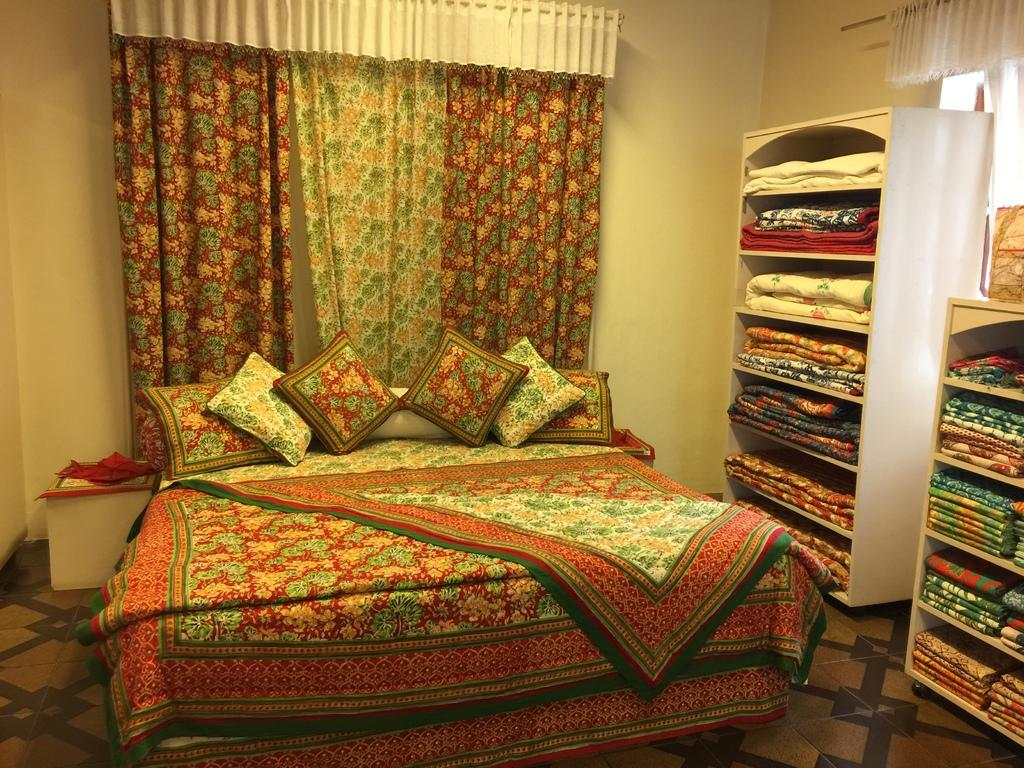What type of furniture is present in the image? There is a bed, table, and cupboards in the image. What can be found on the bed? There are pillows on the bed. What is the material of the walls in the image? The walls are visible in the image, but the material is not specified. What type of window is present in the image? There is a window in the image, but the type is not specified. What is the flooring material in the image? The floor is tiled. What is the purpose of the curtains in the image? The curtains are present in the image, but their purpose is not specified. What is stored in the cupboards? Blankets are present in the cupboards. How many frogs can be seen hopping on the slope in the image? There are no frogs or slopes present in the image. What type of underwear is visible on the table in the image? There is no underwear visible on the table in the image. 